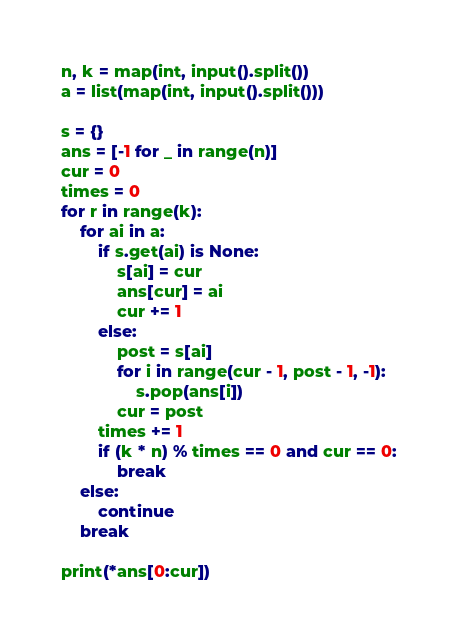Convert code to text. <code><loc_0><loc_0><loc_500><loc_500><_Python_>n, k = map(int, input().split())
a = list(map(int, input().split()))

s = {}
ans = [-1 for _ in range(n)]
cur = 0
times = 0
for r in range(k):
    for ai in a:
        if s.get(ai) is None:
            s[ai] = cur
            ans[cur] = ai
            cur += 1
        else:
            post = s[ai]
            for i in range(cur - 1, post - 1, -1):
                s.pop(ans[i])
            cur = post
        times += 1
        if (k * n) % times == 0 and cur == 0:
            break
    else:
        continue
    break

print(*ans[0:cur])
</code> 